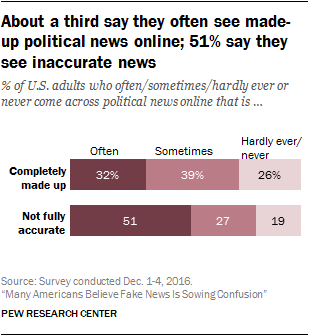Point out several critical features in this image. A made-up percentage of 32% is often used. What about the mid bar says? Sometimes it says... 